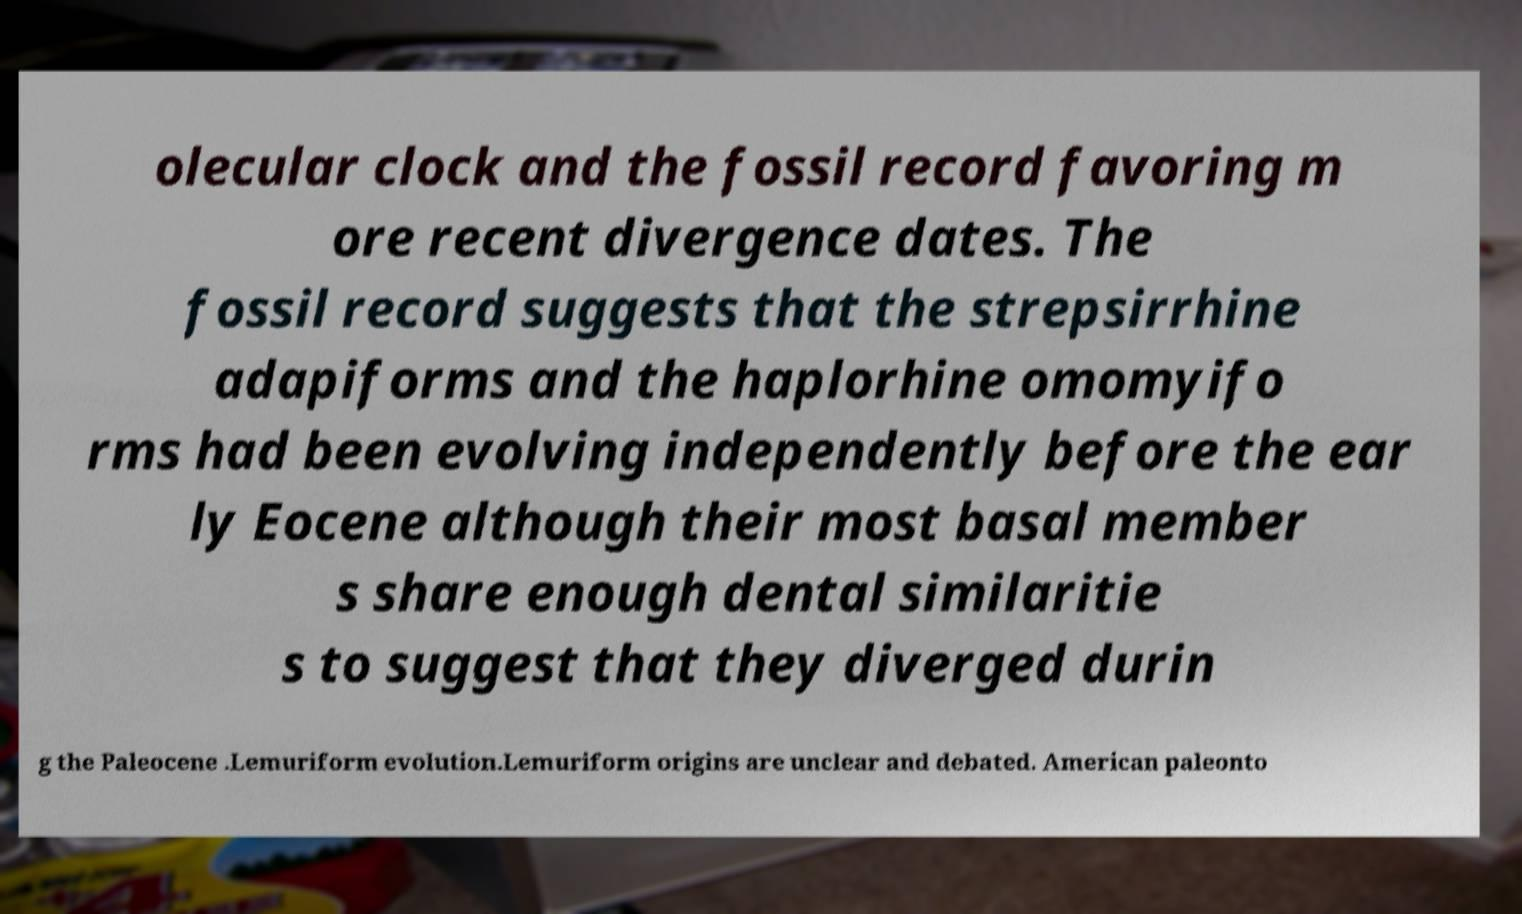Can you accurately transcribe the text from the provided image for me? olecular clock and the fossil record favoring m ore recent divergence dates. The fossil record suggests that the strepsirrhine adapiforms and the haplorhine omomyifo rms had been evolving independently before the ear ly Eocene although their most basal member s share enough dental similaritie s to suggest that they diverged durin g the Paleocene .Lemuriform evolution.Lemuriform origins are unclear and debated. American paleonto 